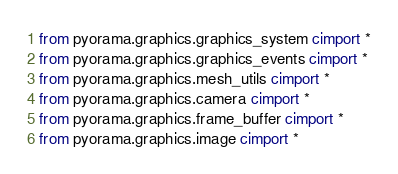Convert code to text. <code><loc_0><loc_0><loc_500><loc_500><_Cython_>from pyorama.graphics.graphics_system cimport *
from pyorama.graphics.graphics_events cimport *
from pyorama.graphics.mesh_utils cimport *
from pyorama.graphics.camera cimport *
from pyorama.graphics.frame_buffer cimport *
from pyorama.graphics.image cimport *</code> 